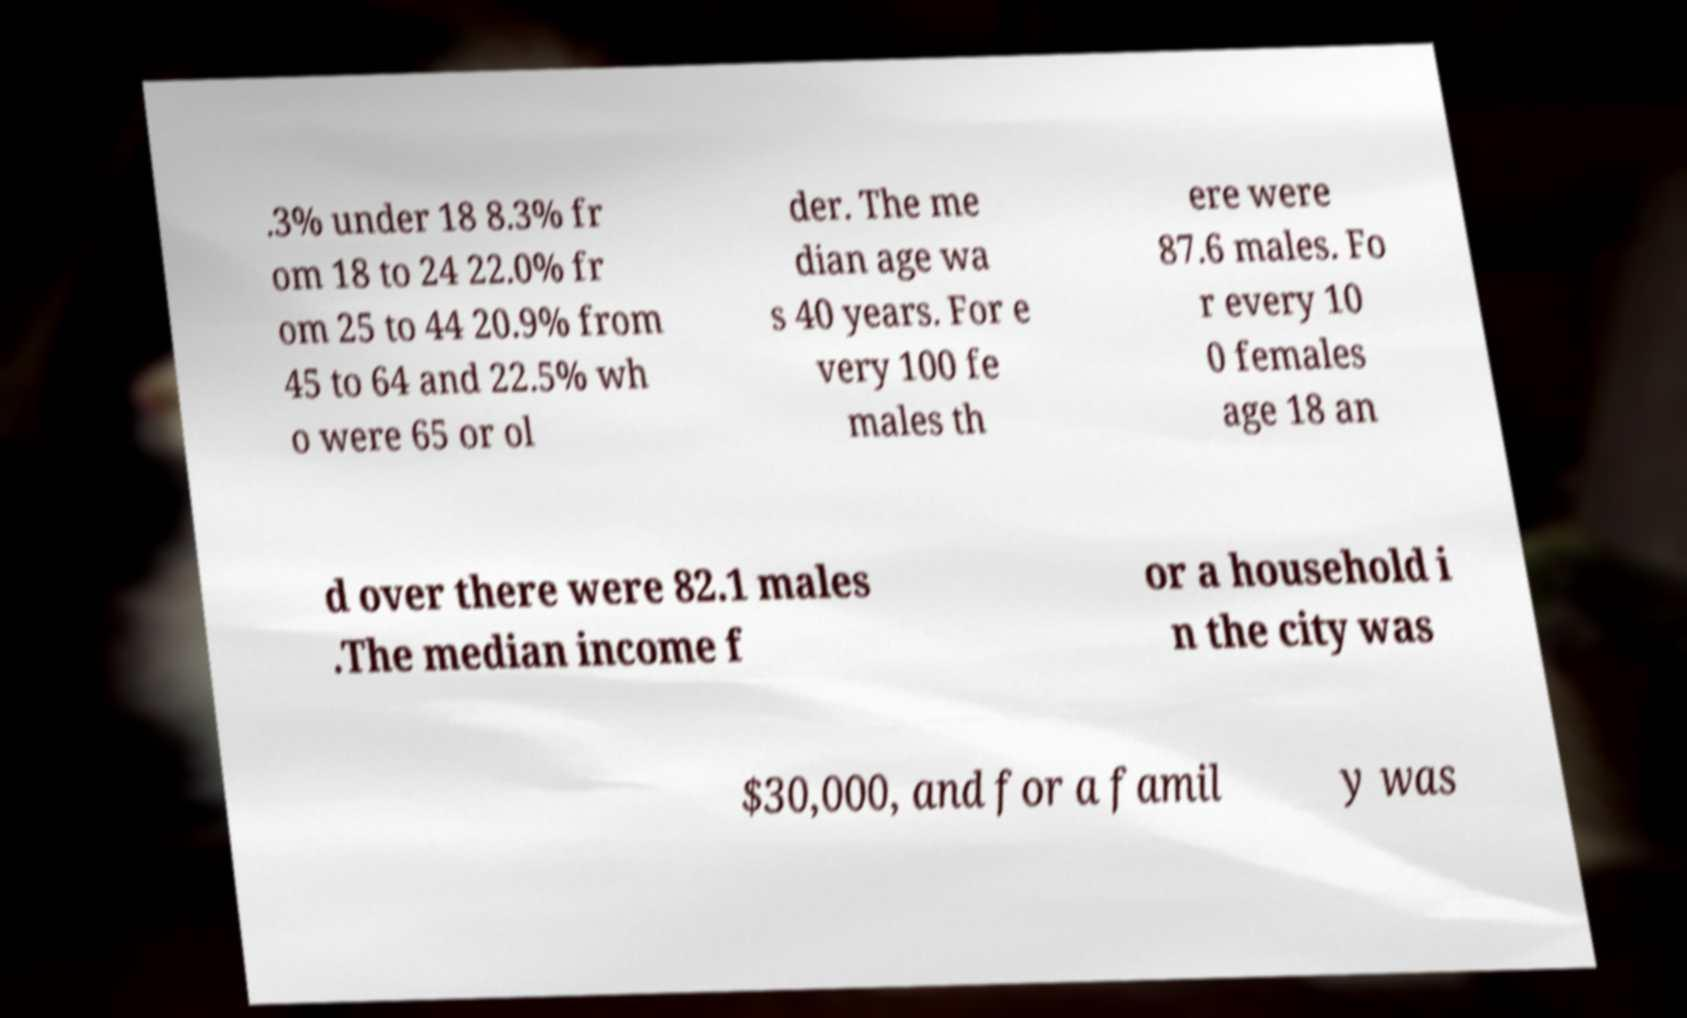Can you read and provide the text displayed in the image?This photo seems to have some interesting text. Can you extract and type it out for me? .3% under 18 8.3% fr om 18 to 24 22.0% fr om 25 to 44 20.9% from 45 to 64 and 22.5% wh o were 65 or ol der. The me dian age wa s 40 years. For e very 100 fe males th ere were 87.6 males. Fo r every 10 0 females age 18 an d over there were 82.1 males .The median income f or a household i n the city was $30,000, and for a famil y was 